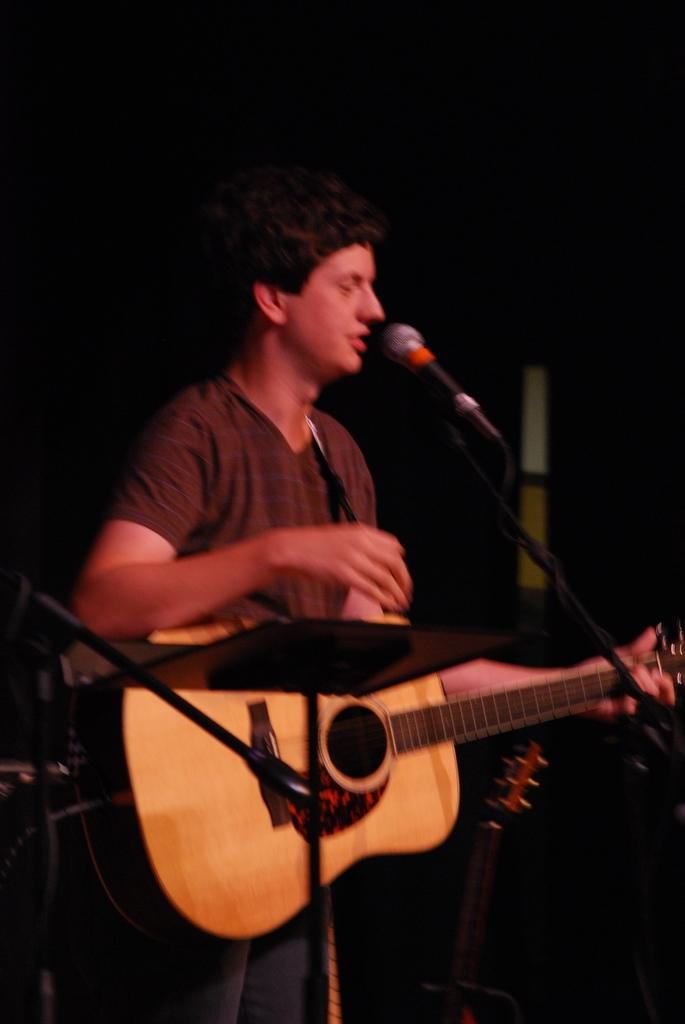Who is the main subject in the image? There is a man in the image. What is the man doing in the image? The man is standing in front of a microphone and playing a guitar. What word is the man saying into the microphone in the image? There is no indication in the image that the man is saying any specific word into the microphone. 